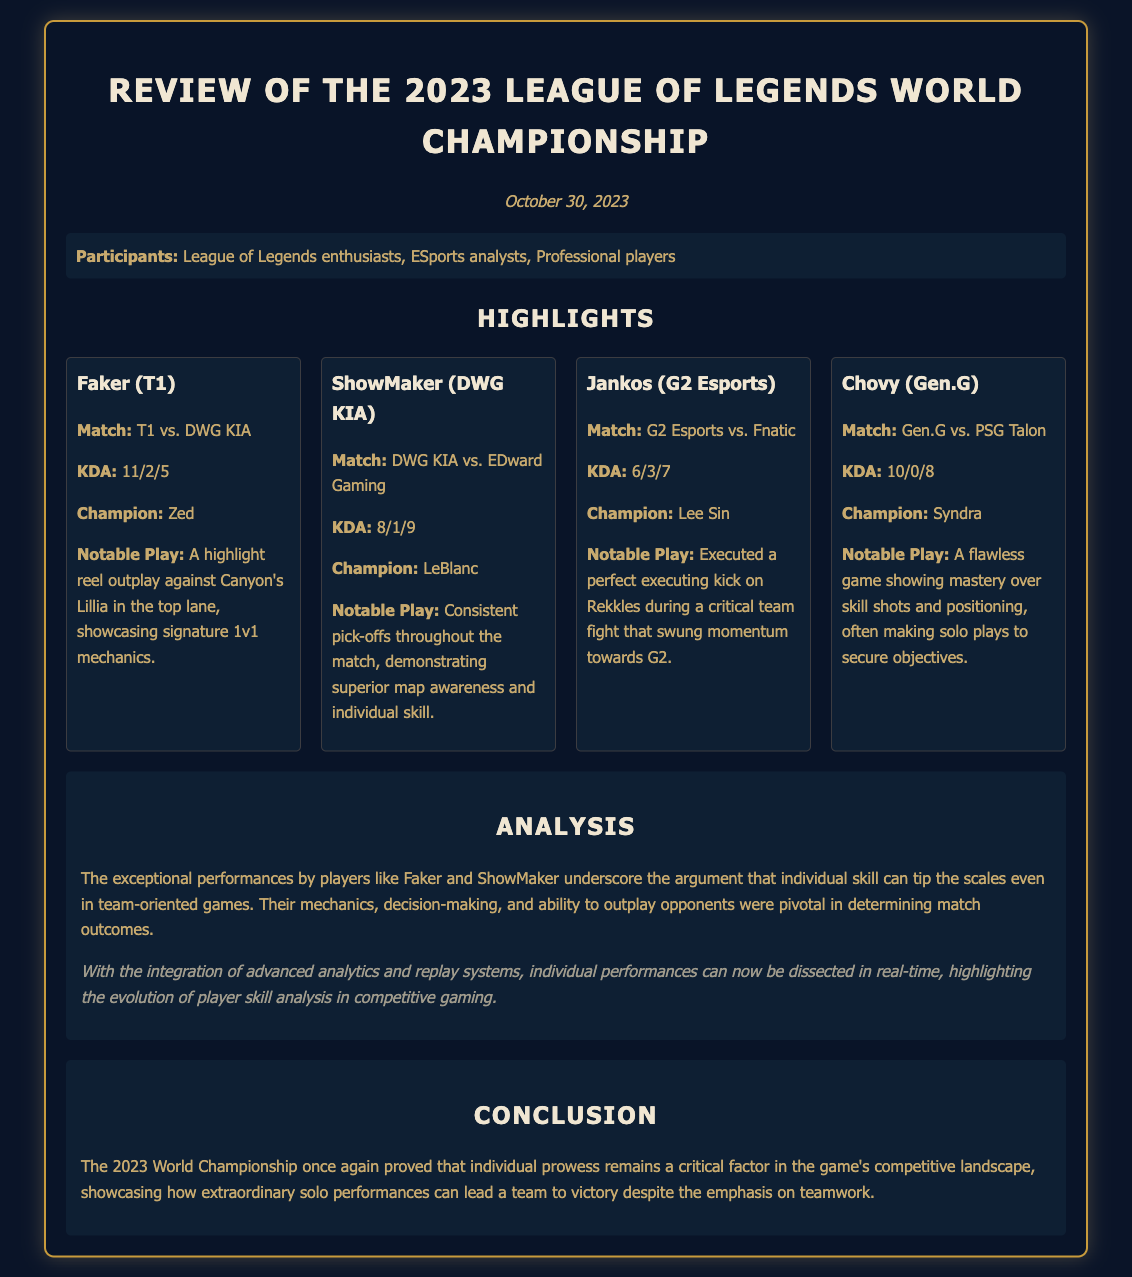What was the date of the meeting? The date of the meeting is mentioned at the beginning of the document.
Answer: October 30, 2023 Who had a KDA of 10/0/8? The KDA stats for each player are listed, and Chovy's KDA is specified.
Answer: Chovy What champion did Faker play? The champion played by Faker is stated in his highlight card.
Answer: Zed What notable play is mentioned for ShowMaker? The document details the notable plays for each standout player, including ShowMaker's.
Answer: Consistent pick-offs throughout the match Which team did Jankos play against? Jankos's match details are provided in his highlight card indicating his opponent.
Answer: Fnatic What is emphasized in the analysis section? The analysis section discusses the impact of individual performances in competitive gaming.
Answer: Individual skill How did Chovy secure objectives? The notable play description for Chovy highlights his skill in securing objectives.
Answer: Making solo plays What type of document is this? The structure and content indicate the nature of this document.
Answer: Meeting minutes 